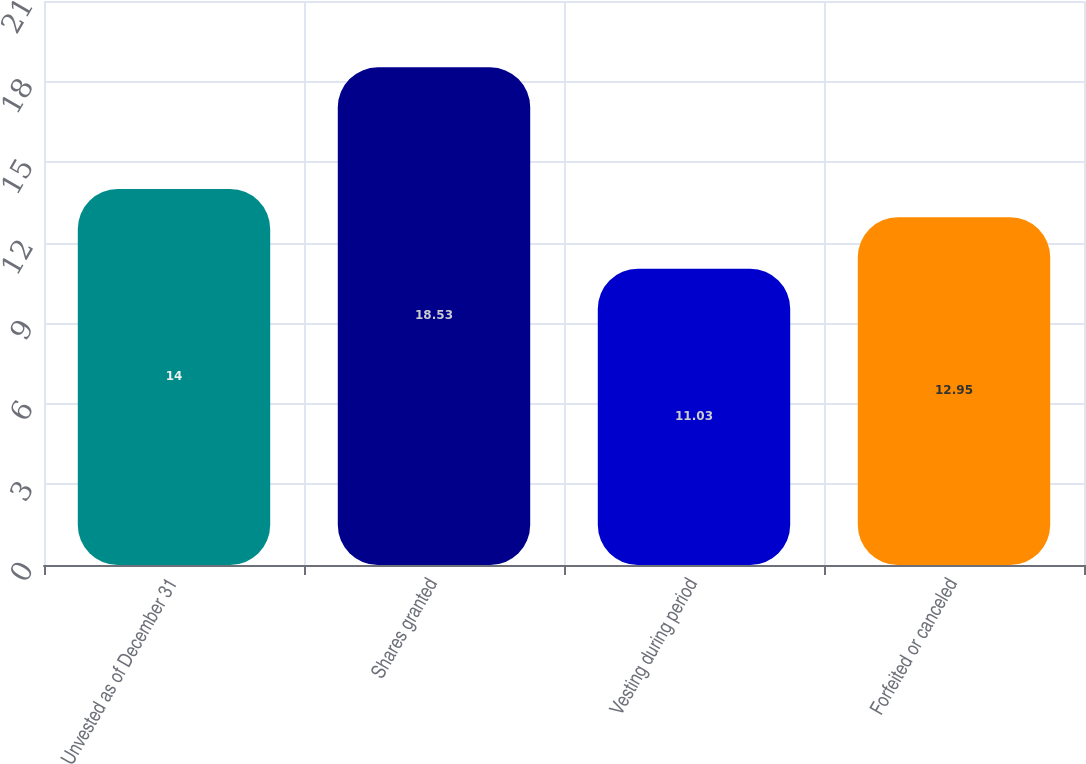<chart> <loc_0><loc_0><loc_500><loc_500><bar_chart><fcel>Unvested as of December 31<fcel>Shares granted<fcel>Vesting during period<fcel>Forfeited or canceled<nl><fcel>14<fcel>18.53<fcel>11.03<fcel>12.95<nl></chart> 